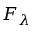Convert formula to latex. <formula><loc_0><loc_0><loc_500><loc_500>F _ { \lambda }</formula> 